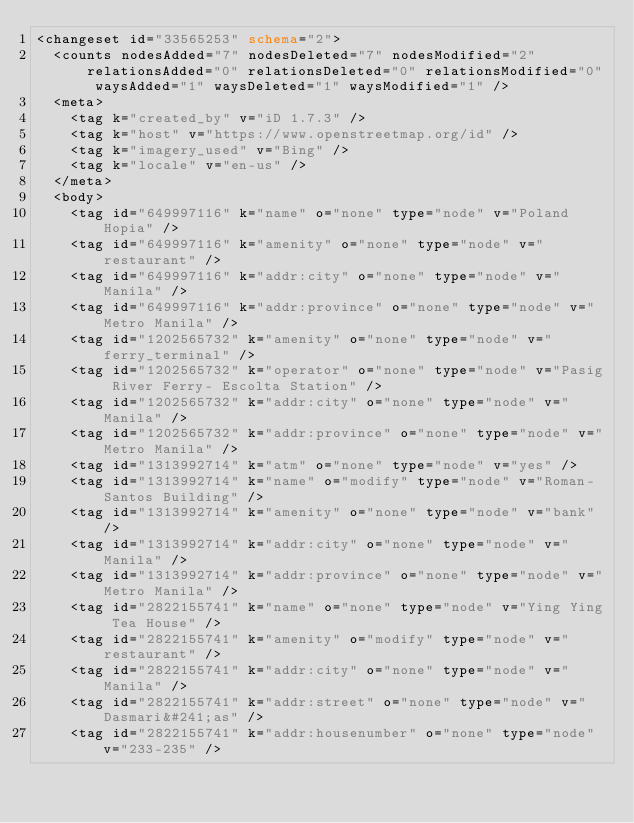Convert code to text. <code><loc_0><loc_0><loc_500><loc_500><_XML_><changeset id="33565253" schema="2">
  <counts nodesAdded="7" nodesDeleted="7" nodesModified="2" relationsAdded="0" relationsDeleted="0" relationsModified="0" waysAdded="1" waysDeleted="1" waysModified="1" />
  <meta>
    <tag k="created_by" v="iD 1.7.3" />
    <tag k="host" v="https://www.openstreetmap.org/id" />
    <tag k="imagery_used" v="Bing" />
    <tag k="locale" v="en-us" />
  </meta>
  <body>
    <tag id="649997116" k="name" o="none" type="node" v="Poland Hopia" />
    <tag id="649997116" k="amenity" o="none" type="node" v="restaurant" />
    <tag id="649997116" k="addr:city" o="none" type="node" v="Manila" />
    <tag id="649997116" k="addr:province" o="none" type="node" v="Metro Manila" />
    <tag id="1202565732" k="amenity" o="none" type="node" v="ferry_terminal" />
    <tag id="1202565732" k="operator" o="none" type="node" v="Pasig River Ferry- Escolta Station" />
    <tag id="1202565732" k="addr:city" o="none" type="node" v="Manila" />
    <tag id="1202565732" k="addr:province" o="none" type="node" v="Metro Manila" />
    <tag id="1313992714" k="atm" o="none" type="node" v="yes" />
    <tag id="1313992714" k="name" o="modify" type="node" v="Roman-Santos Building" />
    <tag id="1313992714" k="amenity" o="none" type="node" v="bank" />
    <tag id="1313992714" k="addr:city" o="none" type="node" v="Manila" />
    <tag id="1313992714" k="addr:province" o="none" type="node" v="Metro Manila" />
    <tag id="2822155741" k="name" o="none" type="node" v="Ying Ying Tea House" />
    <tag id="2822155741" k="amenity" o="modify" type="node" v="restaurant" />
    <tag id="2822155741" k="addr:city" o="none" type="node" v="Manila" />
    <tag id="2822155741" k="addr:street" o="none" type="node" v="Dasmari&#241;as" />
    <tag id="2822155741" k="addr:housenumber" o="none" type="node" v="233-235" /></code> 